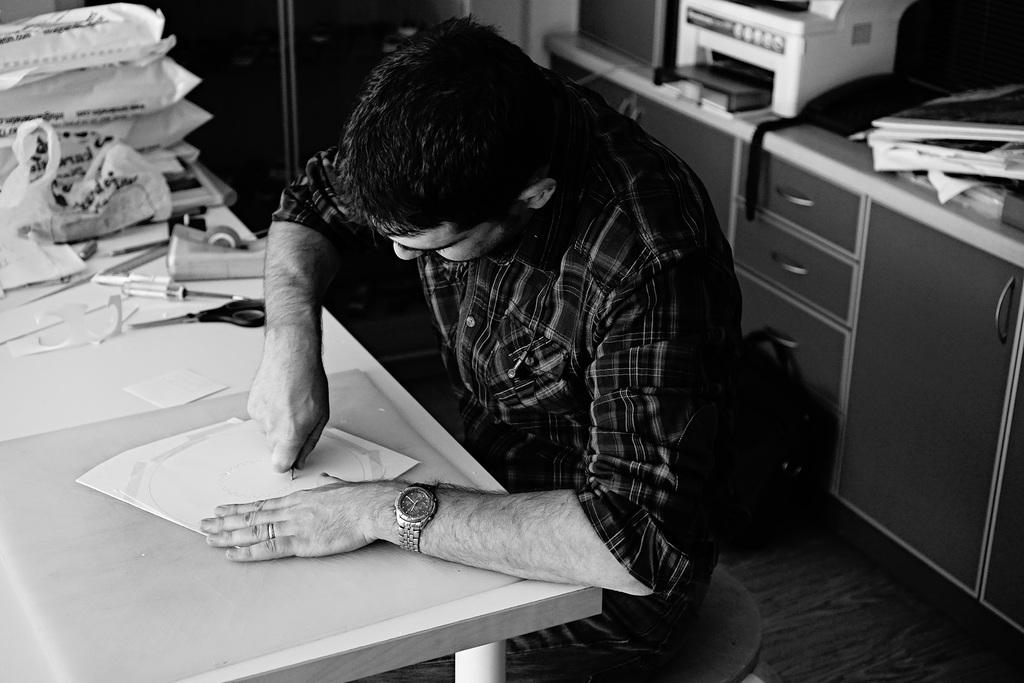Who is in the image? There is a person in the image. What is the person wearing? The person is wearing a black shirt. What is the person doing in the image? The person is doing something on a table. Can you describe the table in the image? The table has covers on it, and there is tape and a scissor on the table. What objects are behind the person in the image? There is a printer and a telephone behind the person. What type of jeans is the boy wearing in the image? There is no boy present in the image, and no jeans are mentioned in the provided facts. 